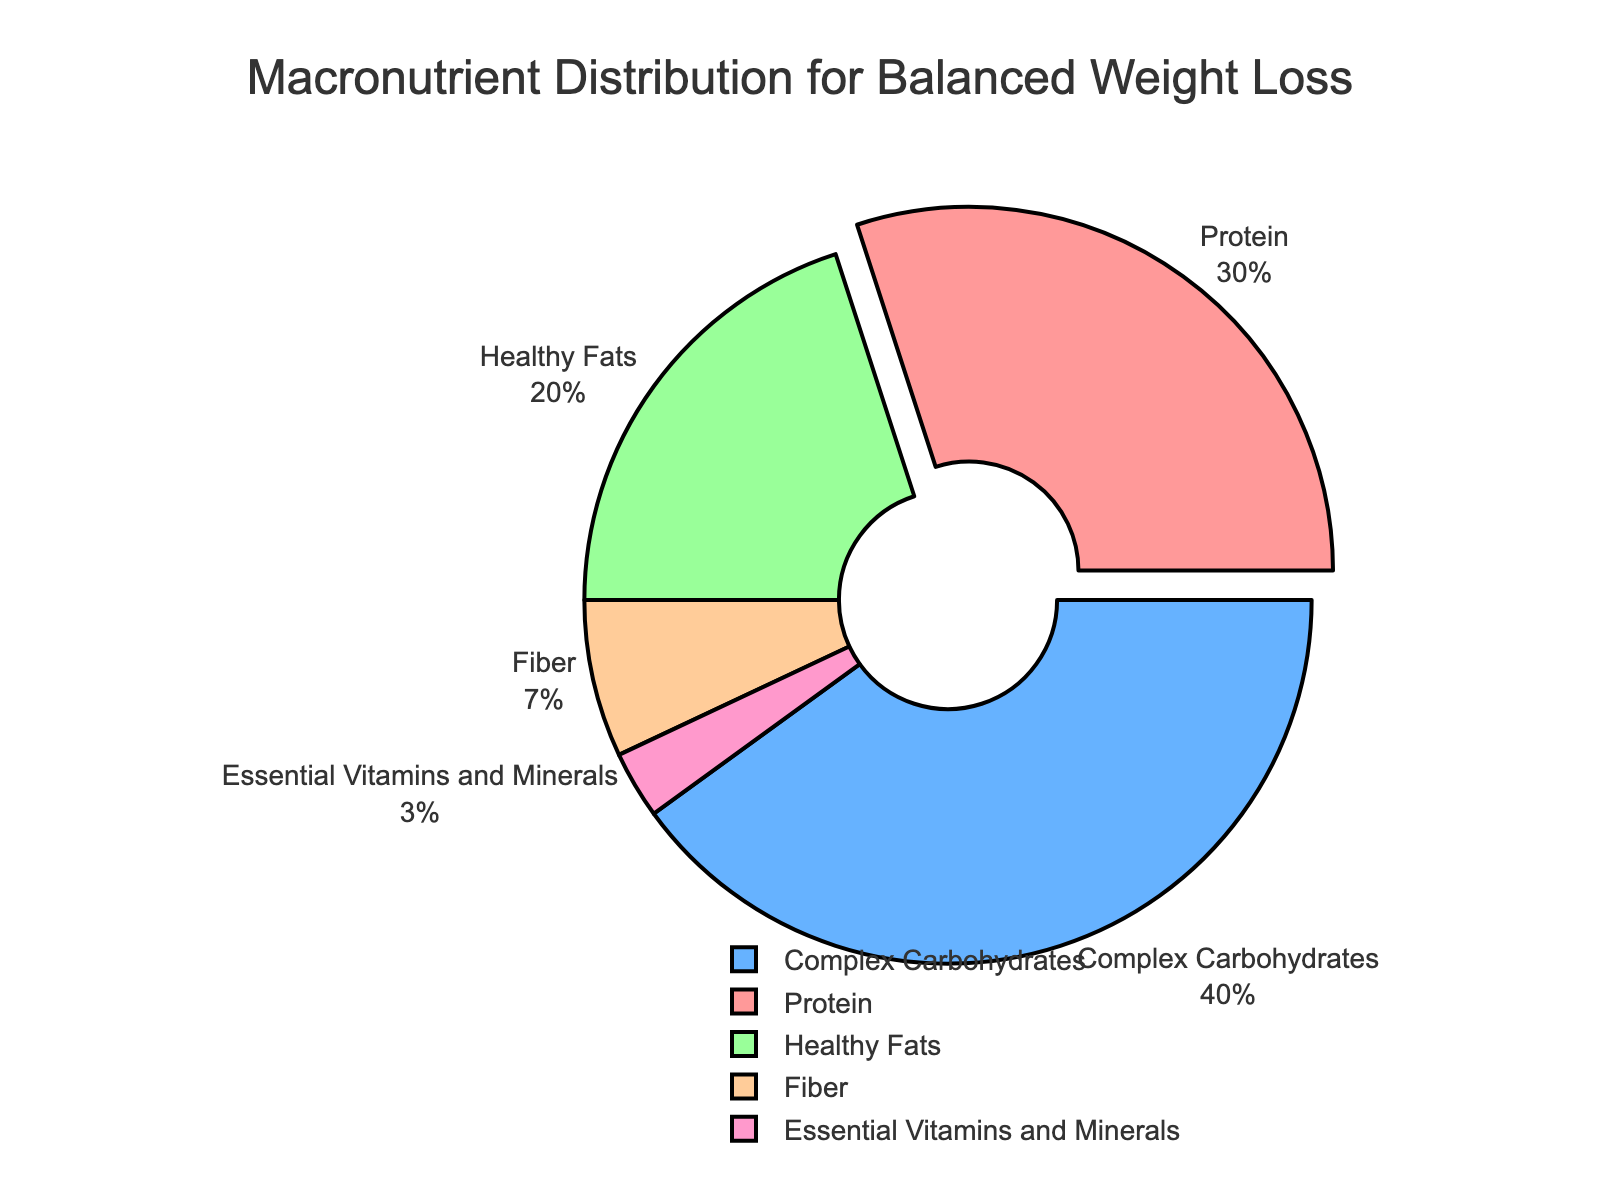What is the percentage of Protein in the macronutrient distribution? Protein constitutes 30% of the total macronutrient distribution, as indicated by the pie chart.
Answer: 30% Which macronutrient has the highest percentage? The macronutrient with the highest percentage on the pie chart is Complex Carbohydrates, which makes up 40% of the distribution.
Answer: Complex Carbohydrates How do the percentages of Healthy Fats and Fiber compare? Healthy Fats are 20% of the total distribution, whereas Fiber is 7%. Therefore, Healthy Fats have a higher percentage than Fiber.
Answer: Healthy Fats have a higher percentage What is the combined percentage of Fiber and Essential Vitamins and Minerals? The percentage of Fiber is 7%, and the percentage of Essential Vitamins and Minerals is 3%. Adding these percentages together: 7% + 3% = 10%.
Answer: 10% What is the difference in percentage between the highest and lowest macronutrients? The highest percentage is from Complex Carbohydrates at 40%, and the lowest is Essential Vitamins and Minerals at 3%. The difference is 40% - 3% = 37%.
Answer: 37% Which macronutrient is represented by the largest slice on the pie chart? The largest slice on the pie chart corresponds to Complex Carbohydrates, which makes up 40% of the distribution.
Answer: Complex Carbohydrates How much larger is the Protein percentage compared to the Essential Vitamins and Minerals percentage? The Protein percentage is 30% while the Essential Vitamins and Minerals percentage is 3%. The difference is 30% - 3% = 27%.
Answer: 27% What is the total percentage of macronutrients excluding Fiber? The percentages of Protein, Complex Carbohydrates, Healthy Fats, and Essential Vitamins and Minerals are 30%, 40%, 20%, and 3% respectively. Summing these up: 30% + 40% + 20% + 3% = 93%.
Answer: 93% Which macronutrient slice is pulled out from the rest of the pie chart? The Protein slice is the one that is pulled out from the rest of the pie chart, highlighting its importance in the distribution.
Answer: Protein 